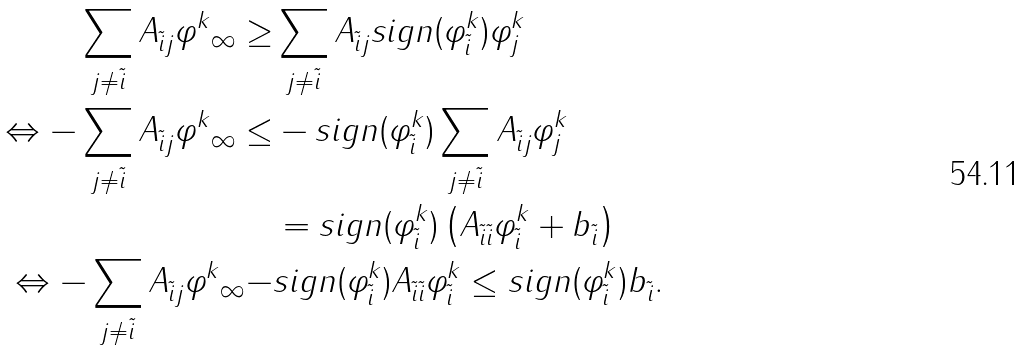Convert formula to latex. <formula><loc_0><loc_0><loc_500><loc_500>\sum _ { j \neq \tilde { i } } A _ { \tilde { i } j } \| \varphi ^ { k } \| _ { \infty } \geq & \sum _ { j \neq \tilde { i } } A _ { \tilde { i } j } s i g n ( \varphi ^ { k } _ { \tilde { i } } ) \varphi ^ { k } _ { j } \\ \Leftrightarrow - \sum _ { j \neq \tilde { i } } A _ { \tilde { i } j } \| \varphi ^ { k } \| _ { \infty } \leq & - s i g n ( \varphi ^ { k } _ { \tilde { i } } ) \sum _ { j \neq \tilde { i } } A _ { \tilde { i } j } \varphi ^ { k } _ { j } \\ & = s i g n ( \varphi ^ { k } _ { \tilde { i } } ) \left ( A _ { \tilde { i } \tilde { i } } \varphi ^ { k } _ { \tilde { i } } + b _ { \tilde { i } } \right ) \\ \Leftrightarrow - \sum _ { j \neq \tilde { i } } A _ { \tilde { i } j } \| \varphi ^ { k } \| _ { \infty } - & s i g n ( \varphi ^ { k } _ { \tilde { i } } ) A _ { \tilde { i } \tilde { i } } \varphi ^ { k } _ { \tilde { i } } \leq s i g n ( \varphi ^ { k } _ { \tilde { i } } ) b _ { \tilde { i } } .</formula> 